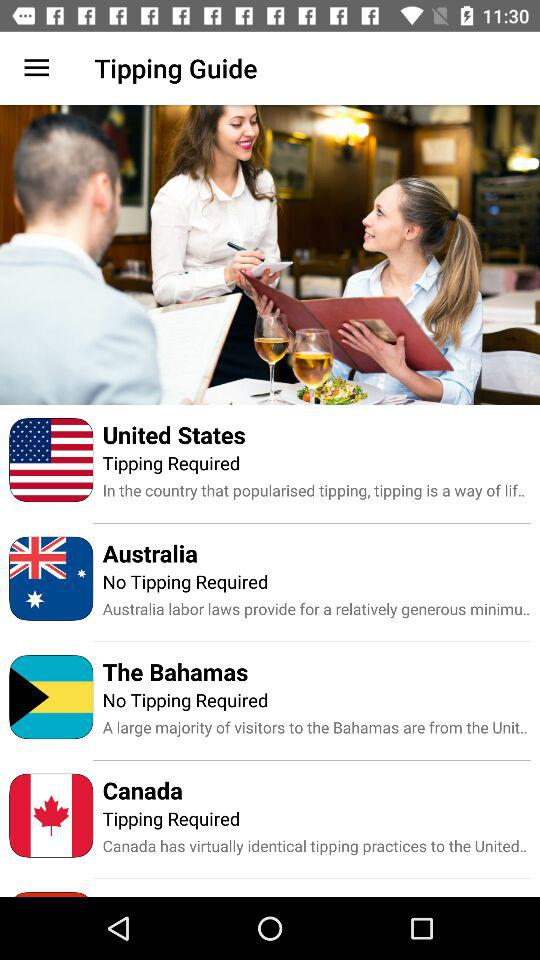Is tipping required in the United States? It is required in the United States. 